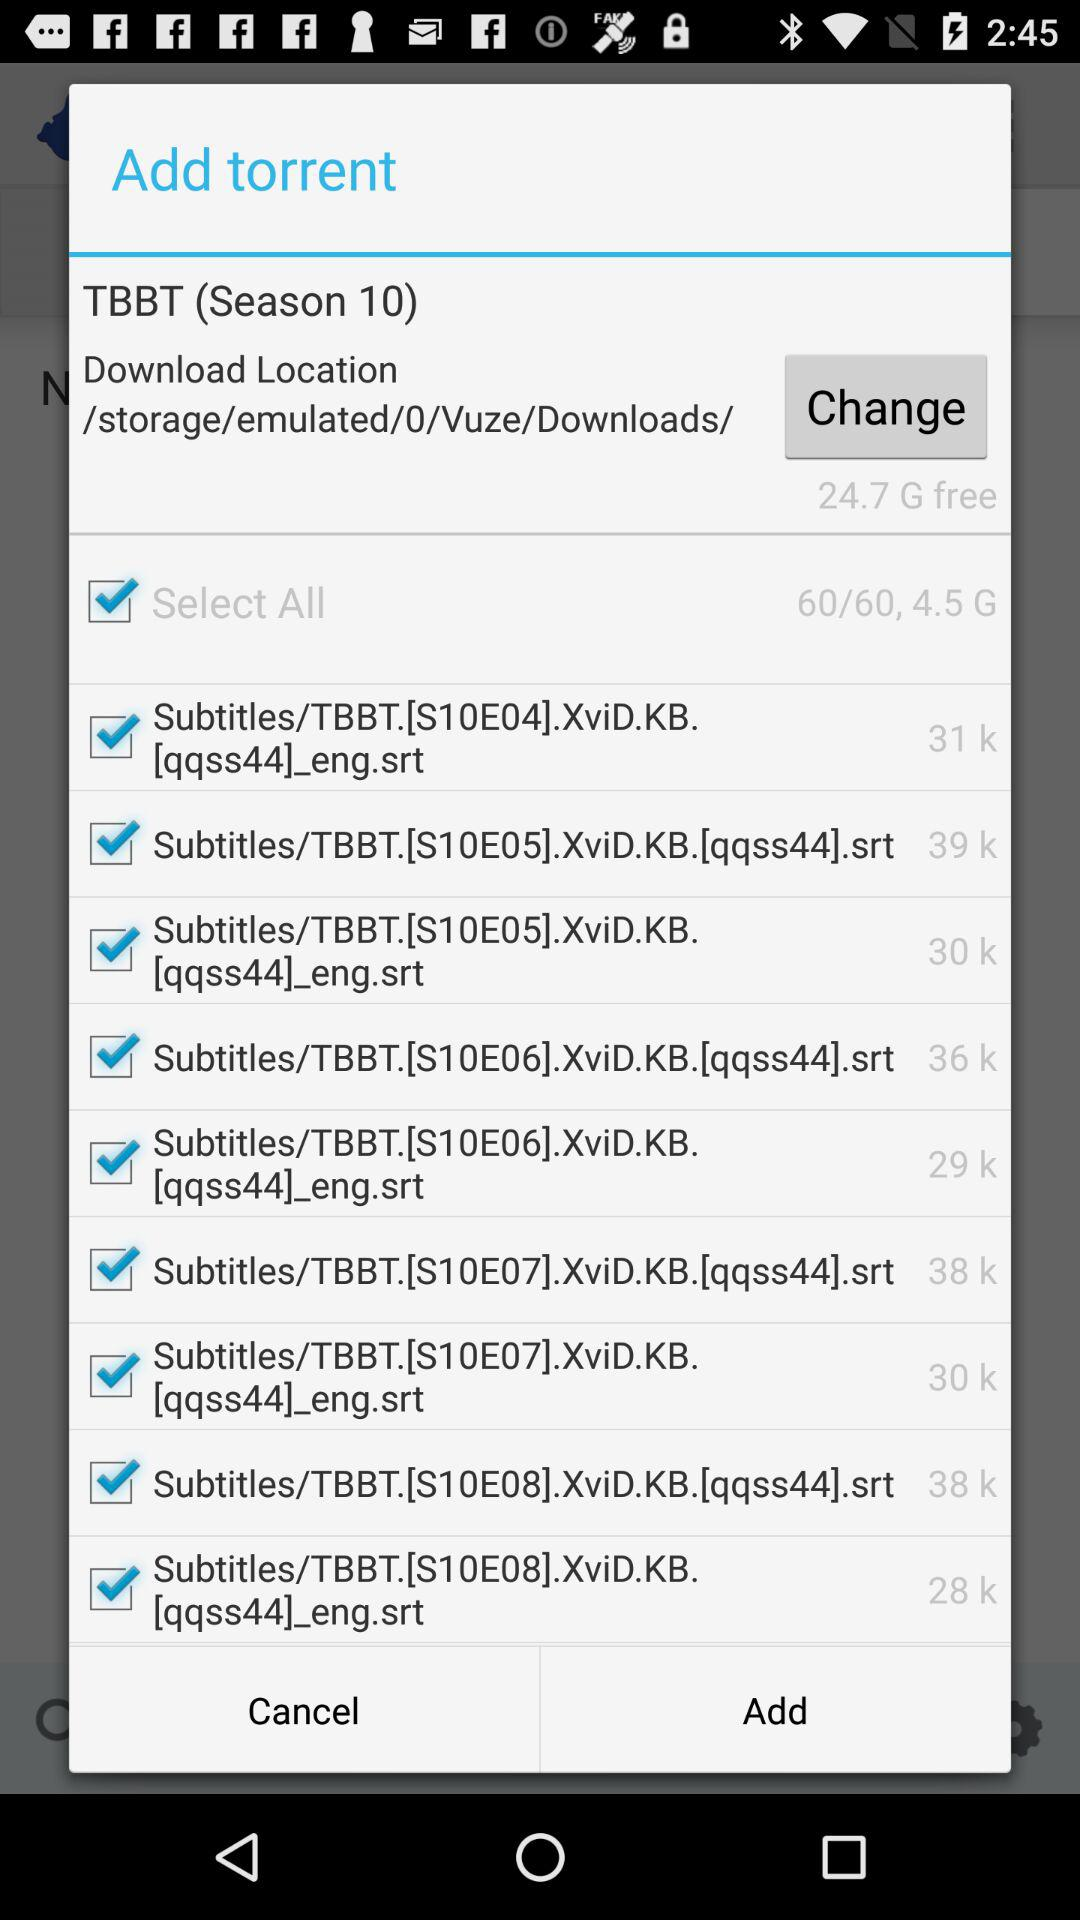How much storage is free? The free storage is 24.7 Gb. 